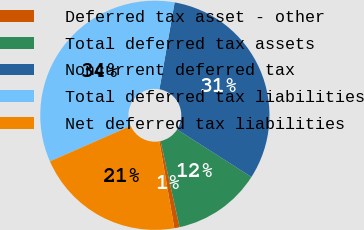Convert chart to OTSL. <chart><loc_0><loc_0><loc_500><loc_500><pie_chart><fcel>Deferred tax asset - other<fcel>Total deferred tax assets<fcel>Noncurrent deferred tax<fcel>Total deferred tax liabilities<fcel>Net deferred tax liabilities<nl><fcel>0.74%<fcel>12.49%<fcel>31.29%<fcel>34.35%<fcel>21.13%<nl></chart> 